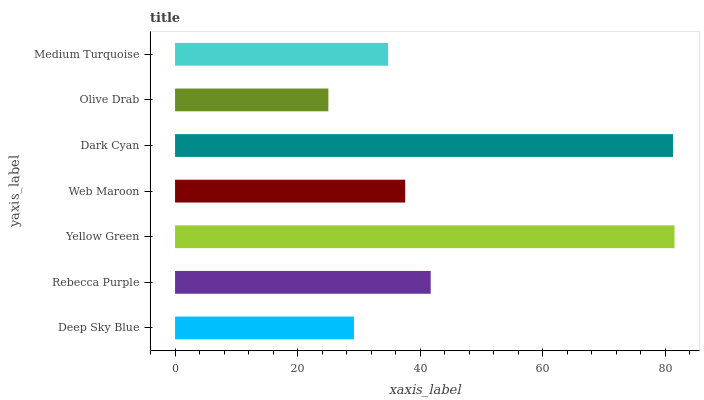Is Olive Drab the minimum?
Answer yes or no. Yes. Is Yellow Green the maximum?
Answer yes or no. Yes. Is Rebecca Purple the minimum?
Answer yes or no. No. Is Rebecca Purple the maximum?
Answer yes or no. No. Is Rebecca Purple greater than Deep Sky Blue?
Answer yes or no. Yes. Is Deep Sky Blue less than Rebecca Purple?
Answer yes or no. Yes. Is Deep Sky Blue greater than Rebecca Purple?
Answer yes or no. No. Is Rebecca Purple less than Deep Sky Blue?
Answer yes or no. No. Is Web Maroon the high median?
Answer yes or no. Yes. Is Web Maroon the low median?
Answer yes or no. Yes. Is Medium Turquoise the high median?
Answer yes or no. No. Is Olive Drab the low median?
Answer yes or no. No. 